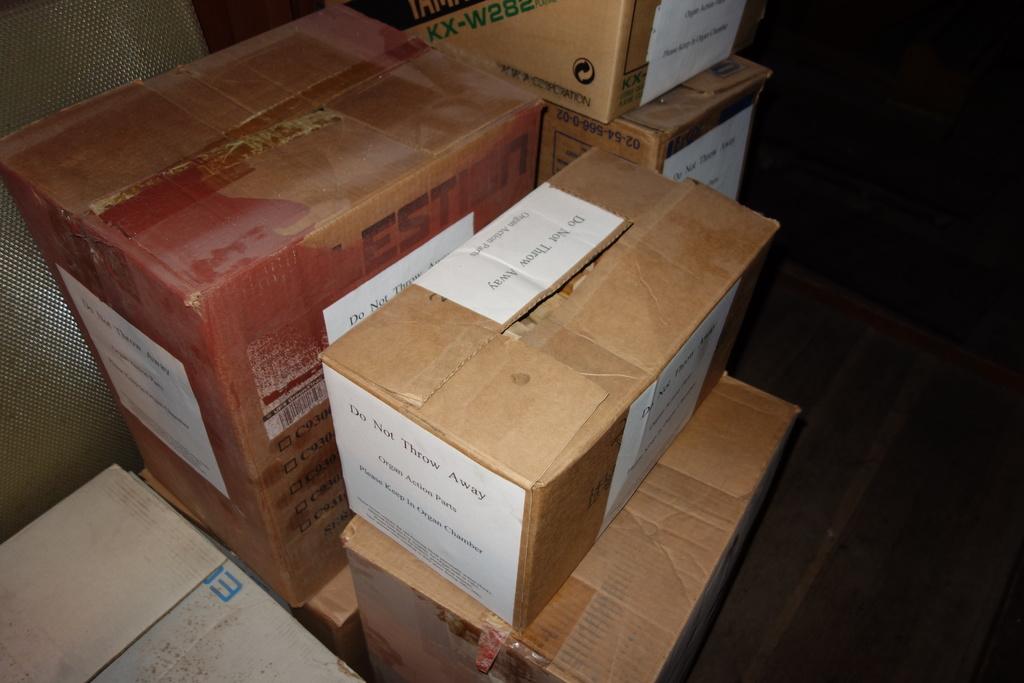What is the box telling us not to do?
Keep it short and to the point. Do not throw away. What kind of parts are in the box?
Your response must be concise. Organ action parts. 